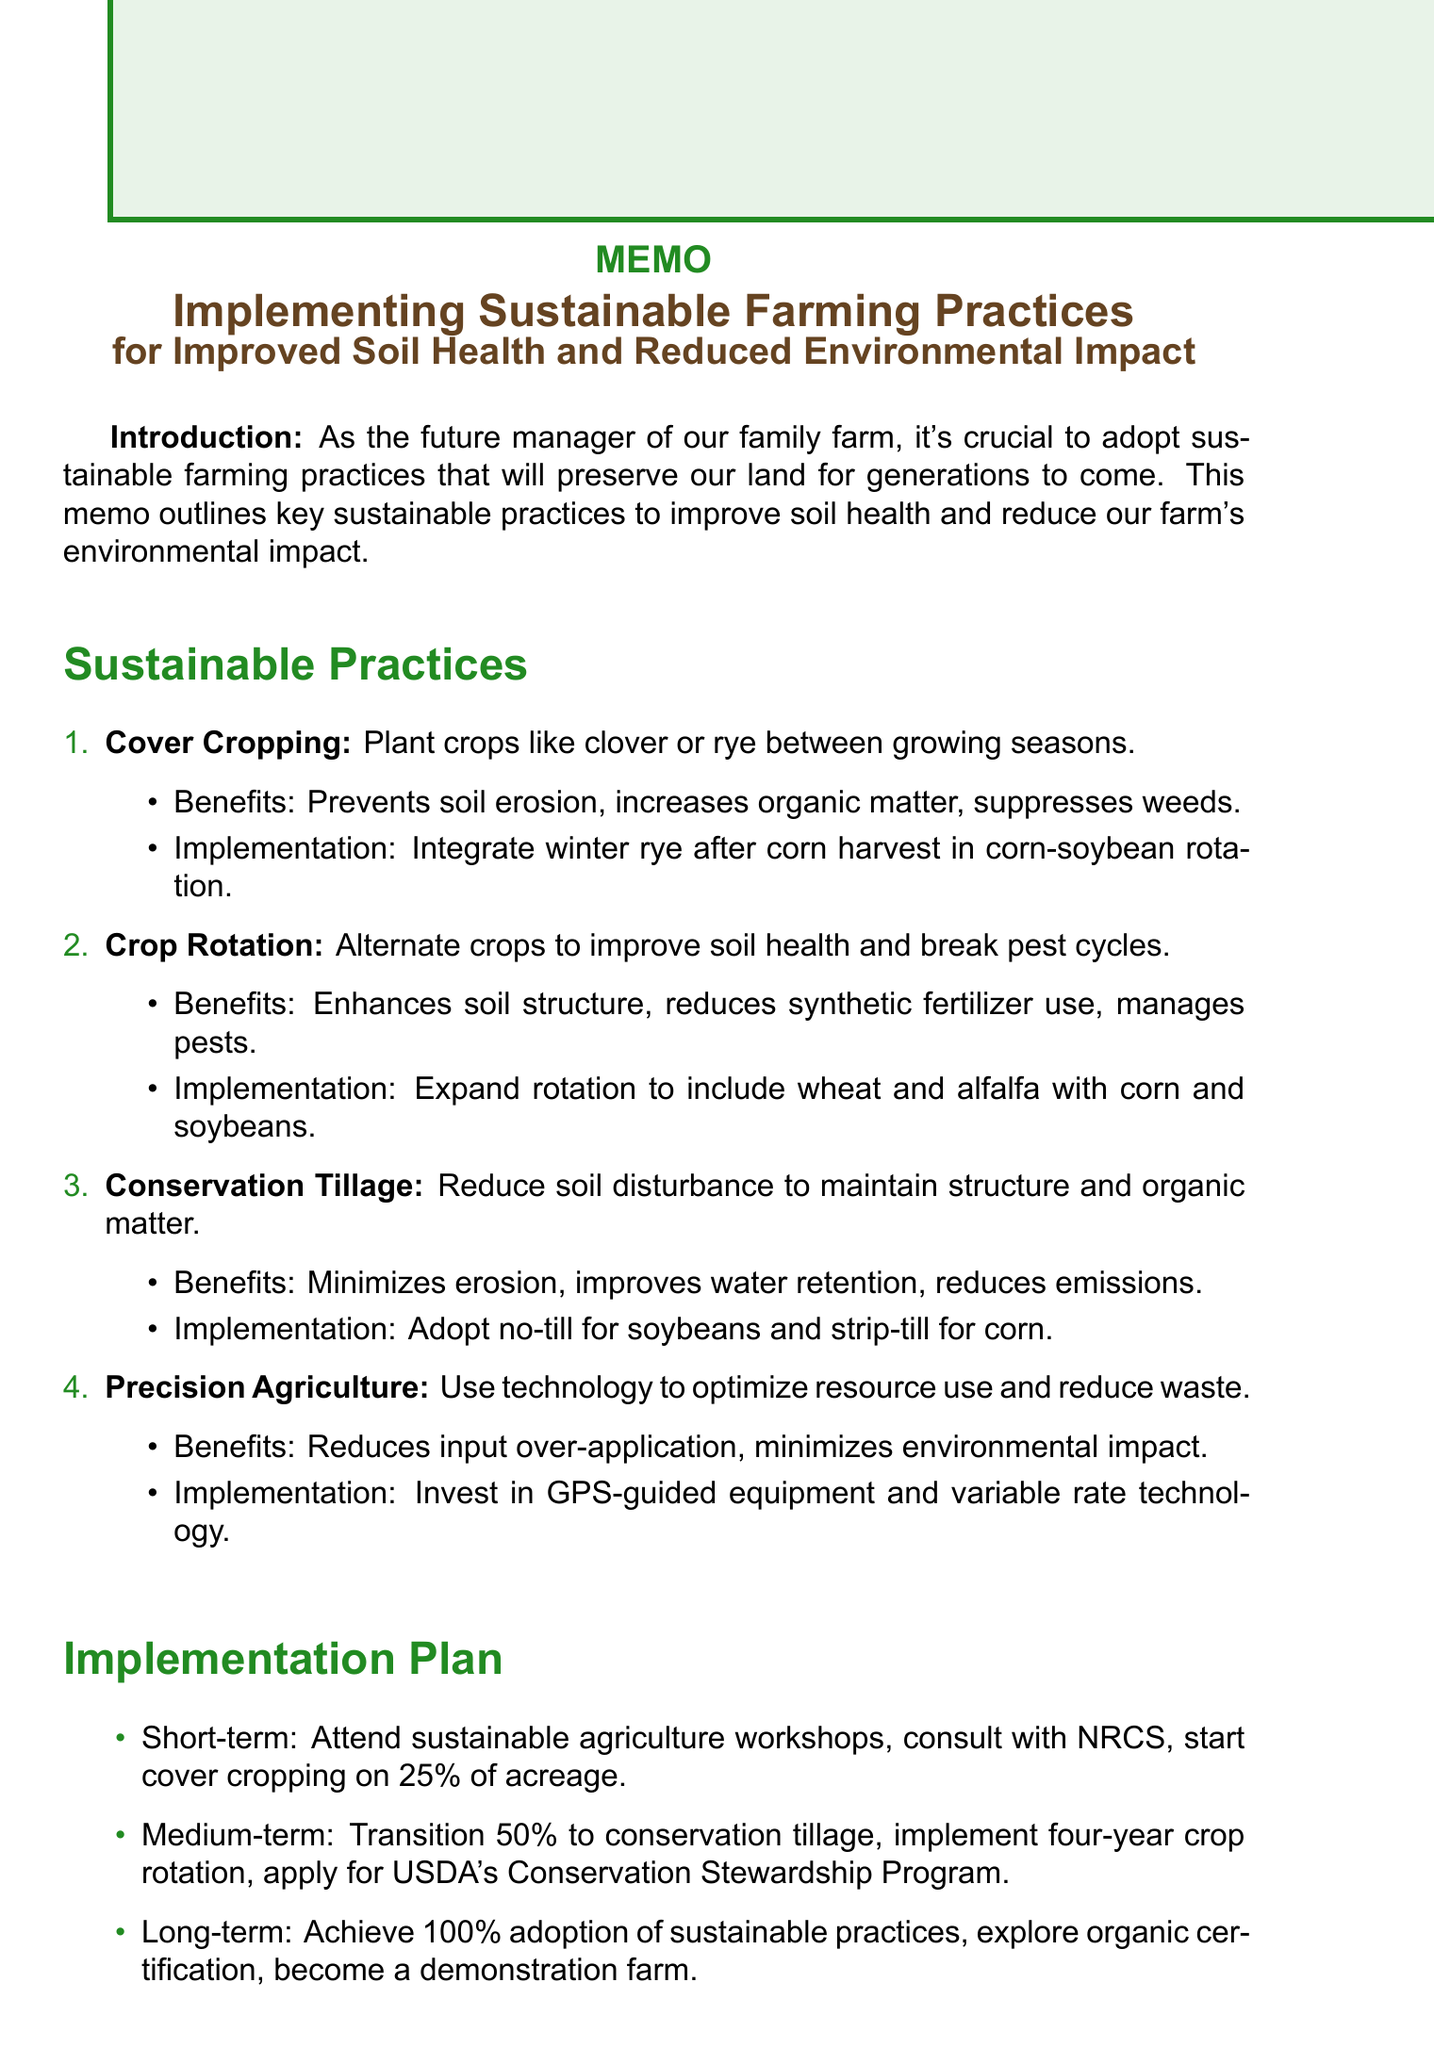what is the title of the memo? The title of the memo is stated at the beginning, which introduces the subject of sustainable farming practices.
Answer: Implementing Sustainable Farming Practices for Improved Soil Health and Reduced Environmental Impact what is one benefit of cover cropping? The benefits of cover cropping include several positive effects on soil, one of which is aimed at preventing erosion.
Answer: Prevents soil erosion what is the initial cost of adopting conservation tillage? The memo lists initial costs for sustainable practices, and conservation tillage includes investment in new equipment.
Answer: Investment in new equipment (e.g., no-till planter) how much of the acreage will begin cover cropping in the short term? The memo specifies that 25 percent of the acreage is planned for cover cropping as a first step.
Answer: 25% what is the long-term goal for the farm? The conclusion outlines ambitious goals for the farm, including achieving full adoption of sustainable practices.
Answer: Achieve 100% adoption of sustainable practices across our farm list one method of precision agriculture mentioned. The memo describes using technology in various ways, one being the investment in GPS-guided equipment.
Answer: GPS-guided equipment what is one outcome of reduced environmental impact? The document outlines several outcomes of adopting sustainable practices, including a specific reduction in greenhouse gas emissions.
Answer: Decreased greenhouse gas emissions which university will provide workshops on sustainable agriculture? The memo outlines the short-term plans, including attending workshops at a specific known institution.
Answer: Iowa State University 